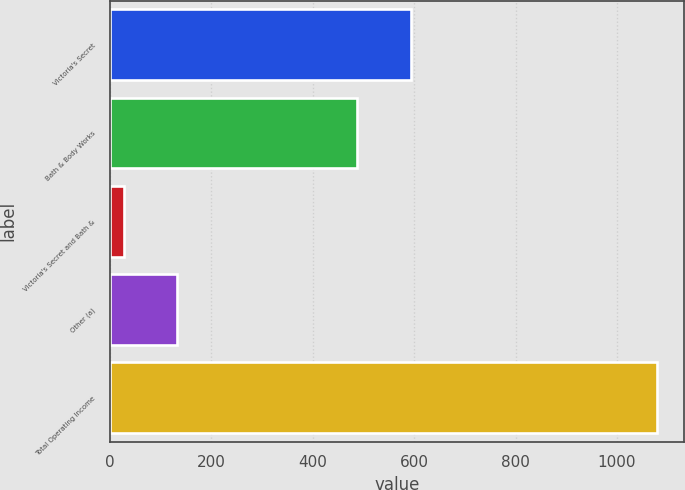Convert chart. <chart><loc_0><loc_0><loc_500><loc_500><bar_chart><fcel>Victoria's Secret<fcel>Bath & Body Works<fcel>Victoria's Secret and Bath &<fcel>Other (a)<fcel>Total Operating Income<nl><fcel>594<fcel>487<fcel>28<fcel>133<fcel>1078<nl></chart> 